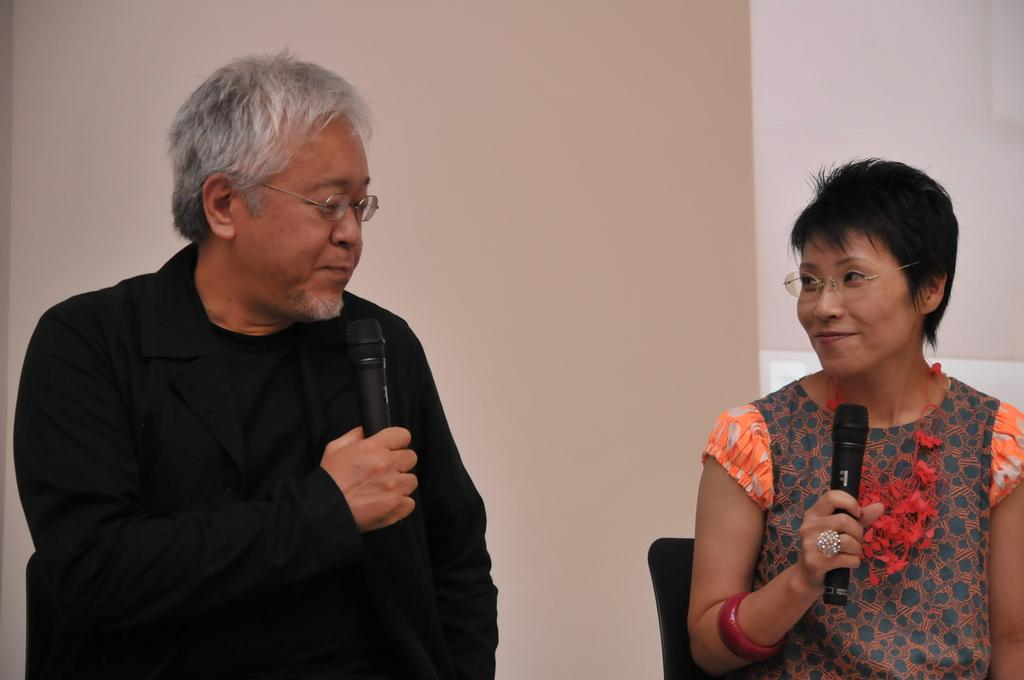How many people are in the image? There are two persons in the image. What are the persons doing in the image? The persons are sitting on chairs and holding microphones. What can be seen on the persons' faces in the image? The persons are wearing glasses. What is visible in the background of the image? There is a wall in the background of the image. What type of carriage can be seen in the image? There is no carriage present in the image. What flavor of soda is the person drinking in the image? There is no soda present in the image. 